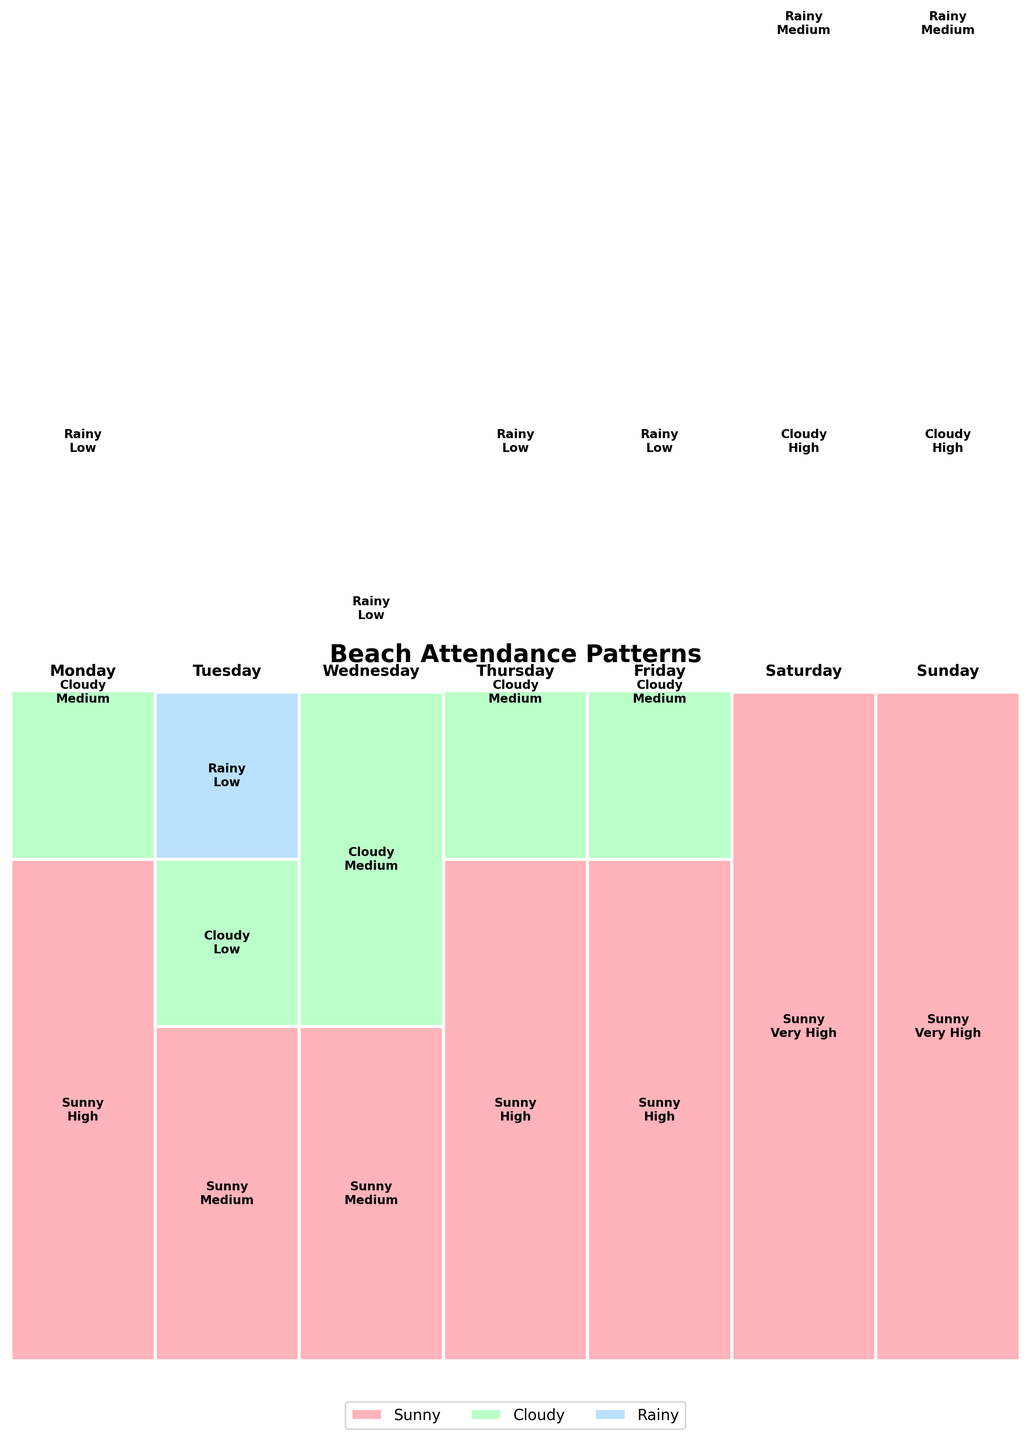What is the title of the figure? The title of the figure is located at the top and usually summarizes the main insight the graph intends to convey. In this case, the title reads "Beach Attendance Patterns".
Answer: Beach Attendance Patterns How does attendance on Saturdays compare across different weather conditions? Saturdays have different blocks color-coded for weather conditions. The heights of these blocks represent the attendance levels. "Sunny" is the highest (Very High), followed by "Cloudy" (High), and "Rainy" (Medium).
Answer: Sunny: Very High, Cloudy: High, Rainy: Medium Which weather condition has the most consistent attendance regardless of the day? By observing the attendance levels across different days for each weather condition. "Rainy" shows consistently "Low" or "Medium" attendance across all days.
Answer: Rainy On which day can we observe the highest overall beach attendance, and under which weather condition? We look for the highest rectangle in the plot, which represents the highest "Very High" attendance. The tallest block is on "Saturday" and "Sunday" under "Sunny" conditions.
Answer: Saturday and Sunday, Sunny Which day has the lowest attendance when it's cloudy? Check the blocks corresponding to "Cloudy" weather and compare their heights. The lowest "Cloudy" block for any day is on "Tuesday" with "Low" attendance.
Answer: Tuesday Are there any days where no "High" or "Very High" attendance is observed? Look for each day's stack of blocks and check if any of them are missing the "High" or "Very High" levels. "Tuesday" is the day without "High" or "Very High" attendance.
Answer: Tuesday How does beach attendance differ between Saturday and Wednesday during cloudy weather? Compare the height of the "Cloudy" blocks on Saturday and Wednesday. Saturday has "High" attendance while Wednesday has "Medium".
Answer: Saturday: High, Wednesday: Medium Which weather condition generally has the highest attendance across all days? Check for the tallest blocks throughout the plot. "Sunny" weather generally has the highest attendance (High or Very High) across multiple days.
Answer: Sunny What is the common trend in attendance for rainy weather throughout the week? Observe the blocks for "Rainy" weather for each day and note their attendance levels. They are consistently "Low" except for the weekend days where it is "Medium".
Answer: Mostly Low, Medium on weekends 